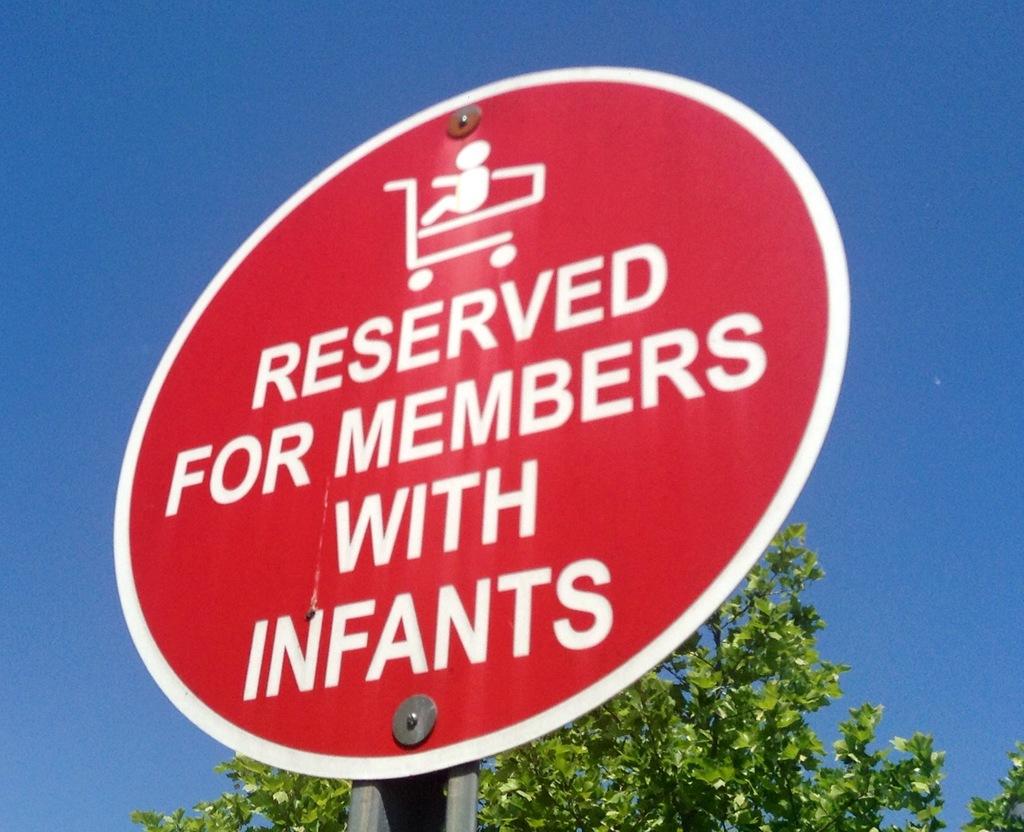What does this sign say is reserved?
Make the answer very short. Members with infants. Is the sign saying this spot is reserved for members or nonmembers?
Your response must be concise. Members. 